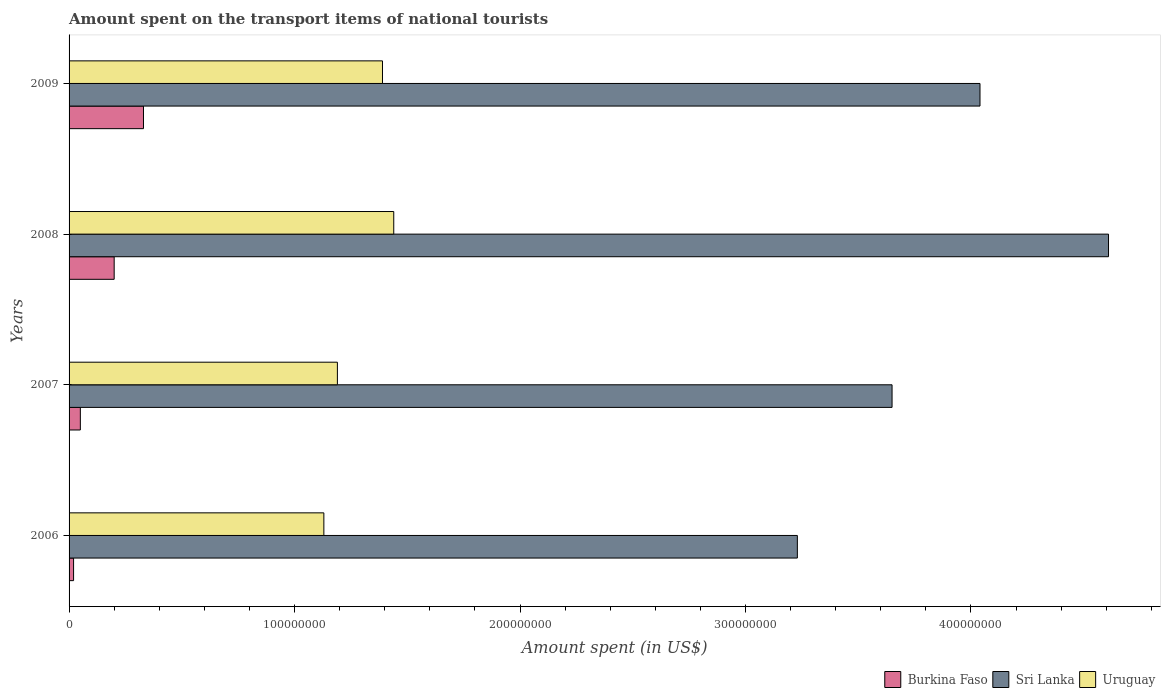How many different coloured bars are there?
Your answer should be compact. 3. How many groups of bars are there?
Keep it short and to the point. 4. Are the number of bars on each tick of the Y-axis equal?
Make the answer very short. Yes. How many bars are there on the 1st tick from the top?
Your answer should be compact. 3. What is the amount spent on the transport items of national tourists in Sri Lanka in 2006?
Offer a very short reply. 3.23e+08. Across all years, what is the maximum amount spent on the transport items of national tourists in Sri Lanka?
Your answer should be compact. 4.61e+08. Across all years, what is the minimum amount spent on the transport items of national tourists in Sri Lanka?
Your answer should be compact. 3.23e+08. In which year was the amount spent on the transport items of national tourists in Uruguay minimum?
Offer a very short reply. 2006. What is the total amount spent on the transport items of national tourists in Burkina Faso in the graph?
Make the answer very short. 6.00e+07. What is the difference between the amount spent on the transport items of national tourists in Burkina Faso in 2007 and that in 2009?
Your response must be concise. -2.80e+07. What is the difference between the amount spent on the transport items of national tourists in Sri Lanka in 2009 and the amount spent on the transport items of national tourists in Burkina Faso in 2007?
Make the answer very short. 3.99e+08. What is the average amount spent on the transport items of national tourists in Sri Lanka per year?
Make the answer very short. 3.88e+08. In the year 2008, what is the difference between the amount spent on the transport items of national tourists in Uruguay and amount spent on the transport items of national tourists in Sri Lanka?
Provide a succinct answer. -3.17e+08. What is the ratio of the amount spent on the transport items of national tourists in Uruguay in 2006 to that in 2008?
Your response must be concise. 0.78. Is the amount spent on the transport items of national tourists in Sri Lanka in 2006 less than that in 2008?
Offer a terse response. Yes. Is the difference between the amount spent on the transport items of national tourists in Uruguay in 2008 and 2009 greater than the difference between the amount spent on the transport items of national tourists in Sri Lanka in 2008 and 2009?
Give a very brief answer. No. What is the difference between the highest and the second highest amount spent on the transport items of national tourists in Burkina Faso?
Your answer should be very brief. 1.30e+07. What is the difference between the highest and the lowest amount spent on the transport items of national tourists in Burkina Faso?
Provide a short and direct response. 3.10e+07. In how many years, is the amount spent on the transport items of national tourists in Burkina Faso greater than the average amount spent on the transport items of national tourists in Burkina Faso taken over all years?
Offer a very short reply. 2. What does the 3rd bar from the top in 2006 represents?
Provide a succinct answer. Burkina Faso. What does the 1st bar from the bottom in 2008 represents?
Your response must be concise. Burkina Faso. Is it the case that in every year, the sum of the amount spent on the transport items of national tourists in Sri Lanka and amount spent on the transport items of national tourists in Uruguay is greater than the amount spent on the transport items of national tourists in Burkina Faso?
Offer a terse response. Yes. How many bars are there?
Your answer should be very brief. 12. Are all the bars in the graph horizontal?
Make the answer very short. Yes. Are the values on the major ticks of X-axis written in scientific E-notation?
Keep it short and to the point. No. Does the graph contain grids?
Ensure brevity in your answer.  No. Where does the legend appear in the graph?
Offer a terse response. Bottom right. How are the legend labels stacked?
Provide a succinct answer. Horizontal. What is the title of the graph?
Offer a terse response. Amount spent on the transport items of national tourists. Does "Honduras" appear as one of the legend labels in the graph?
Ensure brevity in your answer.  No. What is the label or title of the X-axis?
Your answer should be very brief. Amount spent (in US$). What is the Amount spent (in US$) in Burkina Faso in 2006?
Give a very brief answer. 2.00e+06. What is the Amount spent (in US$) of Sri Lanka in 2006?
Offer a very short reply. 3.23e+08. What is the Amount spent (in US$) in Uruguay in 2006?
Your response must be concise. 1.13e+08. What is the Amount spent (in US$) in Sri Lanka in 2007?
Make the answer very short. 3.65e+08. What is the Amount spent (in US$) in Uruguay in 2007?
Keep it short and to the point. 1.19e+08. What is the Amount spent (in US$) of Burkina Faso in 2008?
Your response must be concise. 2.00e+07. What is the Amount spent (in US$) of Sri Lanka in 2008?
Ensure brevity in your answer.  4.61e+08. What is the Amount spent (in US$) of Uruguay in 2008?
Your answer should be very brief. 1.44e+08. What is the Amount spent (in US$) of Burkina Faso in 2009?
Your answer should be compact. 3.30e+07. What is the Amount spent (in US$) of Sri Lanka in 2009?
Your answer should be very brief. 4.04e+08. What is the Amount spent (in US$) of Uruguay in 2009?
Provide a succinct answer. 1.39e+08. Across all years, what is the maximum Amount spent (in US$) of Burkina Faso?
Ensure brevity in your answer.  3.30e+07. Across all years, what is the maximum Amount spent (in US$) of Sri Lanka?
Your answer should be compact. 4.61e+08. Across all years, what is the maximum Amount spent (in US$) of Uruguay?
Provide a succinct answer. 1.44e+08. Across all years, what is the minimum Amount spent (in US$) of Burkina Faso?
Keep it short and to the point. 2.00e+06. Across all years, what is the minimum Amount spent (in US$) of Sri Lanka?
Your response must be concise. 3.23e+08. Across all years, what is the minimum Amount spent (in US$) of Uruguay?
Your answer should be very brief. 1.13e+08. What is the total Amount spent (in US$) in Burkina Faso in the graph?
Offer a terse response. 6.00e+07. What is the total Amount spent (in US$) in Sri Lanka in the graph?
Provide a succinct answer. 1.55e+09. What is the total Amount spent (in US$) in Uruguay in the graph?
Provide a succinct answer. 5.15e+08. What is the difference between the Amount spent (in US$) of Burkina Faso in 2006 and that in 2007?
Provide a succinct answer. -3.00e+06. What is the difference between the Amount spent (in US$) of Sri Lanka in 2006 and that in 2007?
Offer a terse response. -4.20e+07. What is the difference between the Amount spent (in US$) of Uruguay in 2006 and that in 2007?
Your answer should be compact. -6.00e+06. What is the difference between the Amount spent (in US$) in Burkina Faso in 2006 and that in 2008?
Provide a succinct answer. -1.80e+07. What is the difference between the Amount spent (in US$) of Sri Lanka in 2006 and that in 2008?
Offer a very short reply. -1.38e+08. What is the difference between the Amount spent (in US$) in Uruguay in 2006 and that in 2008?
Keep it short and to the point. -3.10e+07. What is the difference between the Amount spent (in US$) of Burkina Faso in 2006 and that in 2009?
Offer a terse response. -3.10e+07. What is the difference between the Amount spent (in US$) in Sri Lanka in 2006 and that in 2009?
Keep it short and to the point. -8.10e+07. What is the difference between the Amount spent (in US$) in Uruguay in 2006 and that in 2009?
Make the answer very short. -2.60e+07. What is the difference between the Amount spent (in US$) of Burkina Faso in 2007 and that in 2008?
Ensure brevity in your answer.  -1.50e+07. What is the difference between the Amount spent (in US$) in Sri Lanka in 2007 and that in 2008?
Provide a short and direct response. -9.60e+07. What is the difference between the Amount spent (in US$) of Uruguay in 2007 and that in 2008?
Keep it short and to the point. -2.50e+07. What is the difference between the Amount spent (in US$) in Burkina Faso in 2007 and that in 2009?
Keep it short and to the point. -2.80e+07. What is the difference between the Amount spent (in US$) in Sri Lanka in 2007 and that in 2009?
Offer a terse response. -3.90e+07. What is the difference between the Amount spent (in US$) in Uruguay in 2007 and that in 2009?
Offer a terse response. -2.00e+07. What is the difference between the Amount spent (in US$) in Burkina Faso in 2008 and that in 2009?
Your response must be concise. -1.30e+07. What is the difference between the Amount spent (in US$) of Sri Lanka in 2008 and that in 2009?
Keep it short and to the point. 5.70e+07. What is the difference between the Amount spent (in US$) of Burkina Faso in 2006 and the Amount spent (in US$) of Sri Lanka in 2007?
Make the answer very short. -3.63e+08. What is the difference between the Amount spent (in US$) in Burkina Faso in 2006 and the Amount spent (in US$) in Uruguay in 2007?
Provide a succinct answer. -1.17e+08. What is the difference between the Amount spent (in US$) in Sri Lanka in 2006 and the Amount spent (in US$) in Uruguay in 2007?
Keep it short and to the point. 2.04e+08. What is the difference between the Amount spent (in US$) of Burkina Faso in 2006 and the Amount spent (in US$) of Sri Lanka in 2008?
Your answer should be compact. -4.59e+08. What is the difference between the Amount spent (in US$) in Burkina Faso in 2006 and the Amount spent (in US$) in Uruguay in 2008?
Give a very brief answer. -1.42e+08. What is the difference between the Amount spent (in US$) in Sri Lanka in 2006 and the Amount spent (in US$) in Uruguay in 2008?
Make the answer very short. 1.79e+08. What is the difference between the Amount spent (in US$) of Burkina Faso in 2006 and the Amount spent (in US$) of Sri Lanka in 2009?
Offer a terse response. -4.02e+08. What is the difference between the Amount spent (in US$) in Burkina Faso in 2006 and the Amount spent (in US$) in Uruguay in 2009?
Keep it short and to the point. -1.37e+08. What is the difference between the Amount spent (in US$) of Sri Lanka in 2006 and the Amount spent (in US$) of Uruguay in 2009?
Your answer should be very brief. 1.84e+08. What is the difference between the Amount spent (in US$) in Burkina Faso in 2007 and the Amount spent (in US$) in Sri Lanka in 2008?
Make the answer very short. -4.56e+08. What is the difference between the Amount spent (in US$) in Burkina Faso in 2007 and the Amount spent (in US$) in Uruguay in 2008?
Provide a succinct answer. -1.39e+08. What is the difference between the Amount spent (in US$) of Sri Lanka in 2007 and the Amount spent (in US$) of Uruguay in 2008?
Offer a very short reply. 2.21e+08. What is the difference between the Amount spent (in US$) of Burkina Faso in 2007 and the Amount spent (in US$) of Sri Lanka in 2009?
Give a very brief answer. -3.99e+08. What is the difference between the Amount spent (in US$) in Burkina Faso in 2007 and the Amount spent (in US$) in Uruguay in 2009?
Offer a very short reply. -1.34e+08. What is the difference between the Amount spent (in US$) in Sri Lanka in 2007 and the Amount spent (in US$) in Uruguay in 2009?
Ensure brevity in your answer.  2.26e+08. What is the difference between the Amount spent (in US$) in Burkina Faso in 2008 and the Amount spent (in US$) in Sri Lanka in 2009?
Your response must be concise. -3.84e+08. What is the difference between the Amount spent (in US$) of Burkina Faso in 2008 and the Amount spent (in US$) of Uruguay in 2009?
Your answer should be compact. -1.19e+08. What is the difference between the Amount spent (in US$) in Sri Lanka in 2008 and the Amount spent (in US$) in Uruguay in 2009?
Give a very brief answer. 3.22e+08. What is the average Amount spent (in US$) of Burkina Faso per year?
Keep it short and to the point. 1.50e+07. What is the average Amount spent (in US$) of Sri Lanka per year?
Provide a succinct answer. 3.88e+08. What is the average Amount spent (in US$) of Uruguay per year?
Offer a very short reply. 1.29e+08. In the year 2006, what is the difference between the Amount spent (in US$) in Burkina Faso and Amount spent (in US$) in Sri Lanka?
Offer a very short reply. -3.21e+08. In the year 2006, what is the difference between the Amount spent (in US$) in Burkina Faso and Amount spent (in US$) in Uruguay?
Your response must be concise. -1.11e+08. In the year 2006, what is the difference between the Amount spent (in US$) of Sri Lanka and Amount spent (in US$) of Uruguay?
Keep it short and to the point. 2.10e+08. In the year 2007, what is the difference between the Amount spent (in US$) of Burkina Faso and Amount spent (in US$) of Sri Lanka?
Ensure brevity in your answer.  -3.60e+08. In the year 2007, what is the difference between the Amount spent (in US$) of Burkina Faso and Amount spent (in US$) of Uruguay?
Make the answer very short. -1.14e+08. In the year 2007, what is the difference between the Amount spent (in US$) of Sri Lanka and Amount spent (in US$) of Uruguay?
Make the answer very short. 2.46e+08. In the year 2008, what is the difference between the Amount spent (in US$) of Burkina Faso and Amount spent (in US$) of Sri Lanka?
Your answer should be compact. -4.41e+08. In the year 2008, what is the difference between the Amount spent (in US$) of Burkina Faso and Amount spent (in US$) of Uruguay?
Give a very brief answer. -1.24e+08. In the year 2008, what is the difference between the Amount spent (in US$) of Sri Lanka and Amount spent (in US$) of Uruguay?
Your answer should be compact. 3.17e+08. In the year 2009, what is the difference between the Amount spent (in US$) of Burkina Faso and Amount spent (in US$) of Sri Lanka?
Ensure brevity in your answer.  -3.71e+08. In the year 2009, what is the difference between the Amount spent (in US$) of Burkina Faso and Amount spent (in US$) of Uruguay?
Ensure brevity in your answer.  -1.06e+08. In the year 2009, what is the difference between the Amount spent (in US$) of Sri Lanka and Amount spent (in US$) of Uruguay?
Make the answer very short. 2.65e+08. What is the ratio of the Amount spent (in US$) of Burkina Faso in 2006 to that in 2007?
Give a very brief answer. 0.4. What is the ratio of the Amount spent (in US$) in Sri Lanka in 2006 to that in 2007?
Your answer should be very brief. 0.88. What is the ratio of the Amount spent (in US$) of Uruguay in 2006 to that in 2007?
Offer a very short reply. 0.95. What is the ratio of the Amount spent (in US$) in Burkina Faso in 2006 to that in 2008?
Offer a very short reply. 0.1. What is the ratio of the Amount spent (in US$) in Sri Lanka in 2006 to that in 2008?
Give a very brief answer. 0.7. What is the ratio of the Amount spent (in US$) in Uruguay in 2006 to that in 2008?
Your answer should be very brief. 0.78. What is the ratio of the Amount spent (in US$) of Burkina Faso in 2006 to that in 2009?
Offer a terse response. 0.06. What is the ratio of the Amount spent (in US$) in Sri Lanka in 2006 to that in 2009?
Your answer should be very brief. 0.8. What is the ratio of the Amount spent (in US$) in Uruguay in 2006 to that in 2009?
Provide a short and direct response. 0.81. What is the ratio of the Amount spent (in US$) in Burkina Faso in 2007 to that in 2008?
Offer a very short reply. 0.25. What is the ratio of the Amount spent (in US$) of Sri Lanka in 2007 to that in 2008?
Give a very brief answer. 0.79. What is the ratio of the Amount spent (in US$) of Uruguay in 2007 to that in 2008?
Give a very brief answer. 0.83. What is the ratio of the Amount spent (in US$) of Burkina Faso in 2007 to that in 2009?
Give a very brief answer. 0.15. What is the ratio of the Amount spent (in US$) in Sri Lanka in 2007 to that in 2009?
Keep it short and to the point. 0.9. What is the ratio of the Amount spent (in US$) of Uruguay in 2007 to that in 2009?
Give a very brief answer. 0.86. What is the ratio of the Amount spent (in US$) of Burkina Faso in 2008 to that in 2009?
Ensure brevity in your answer.  0.61. What is the ratio of the Amount spent (in US$) of Sri Lanka in 2008 to that in 2009?
Provide a short and direct response. 1.14. What is the ratio of the Amount spent (in US$) in Uruguay in 2008 to that in 2009?
Keep it short and to the point. 1.04. What is the difference between the highest and the second highest Amount spent (in US$) of Burkina Faso?
Your answer should be compact. 1.30e+07. What is the difference between the highest and the second highest Amount spent (in US$) in Sri Lanka?
Provide a short and direct response. 5.70e+07. What is the difference between the highest and the lowest Amount spent (in US$) of Burkina Faso?
Ensure brevity in your answer.  3.10e+07. What is the difference between the highest and the lowest Amount spent (in US$) in Sri Lanka?
Provide a short and direct response. 1.38e+08. What is the difference between the highest and the lowest Amount spent (in US$) of Uruguay?
Offer a very short reply. 3.10e+07. 